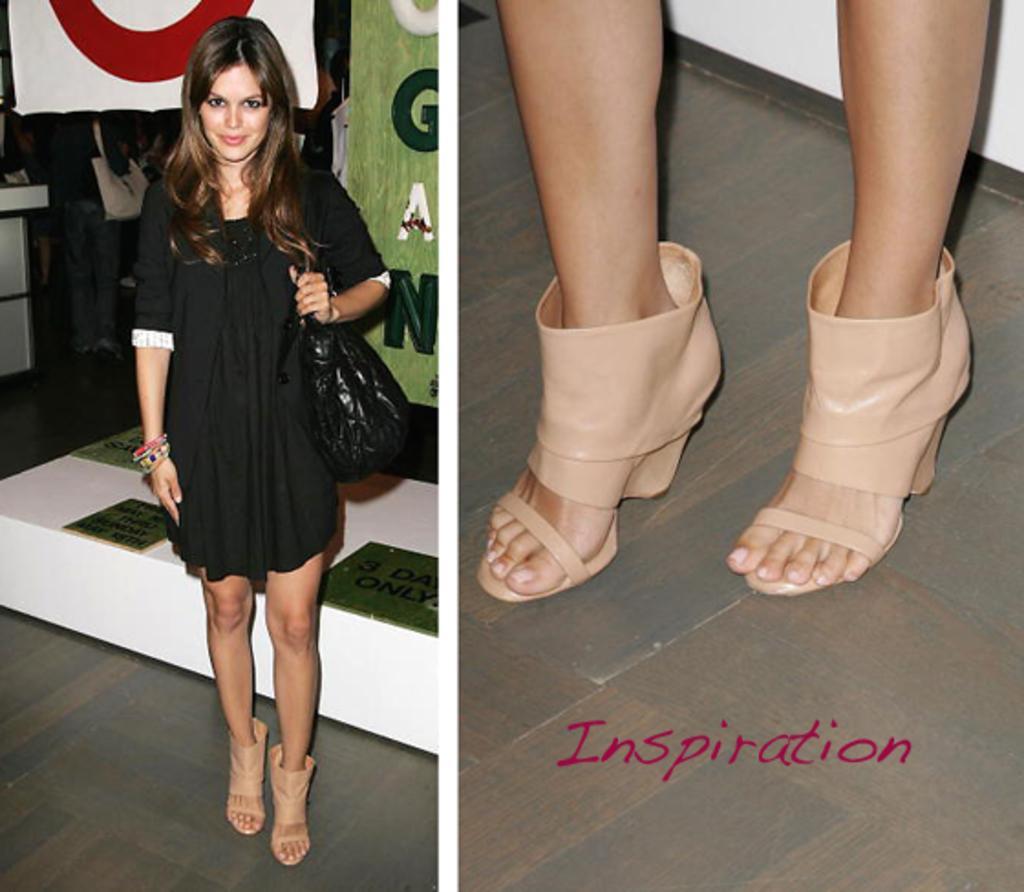Can you describe this image briefly? In this image I can see a person standing wearing black dress and black bag. I can also see a sandals in cream color. 